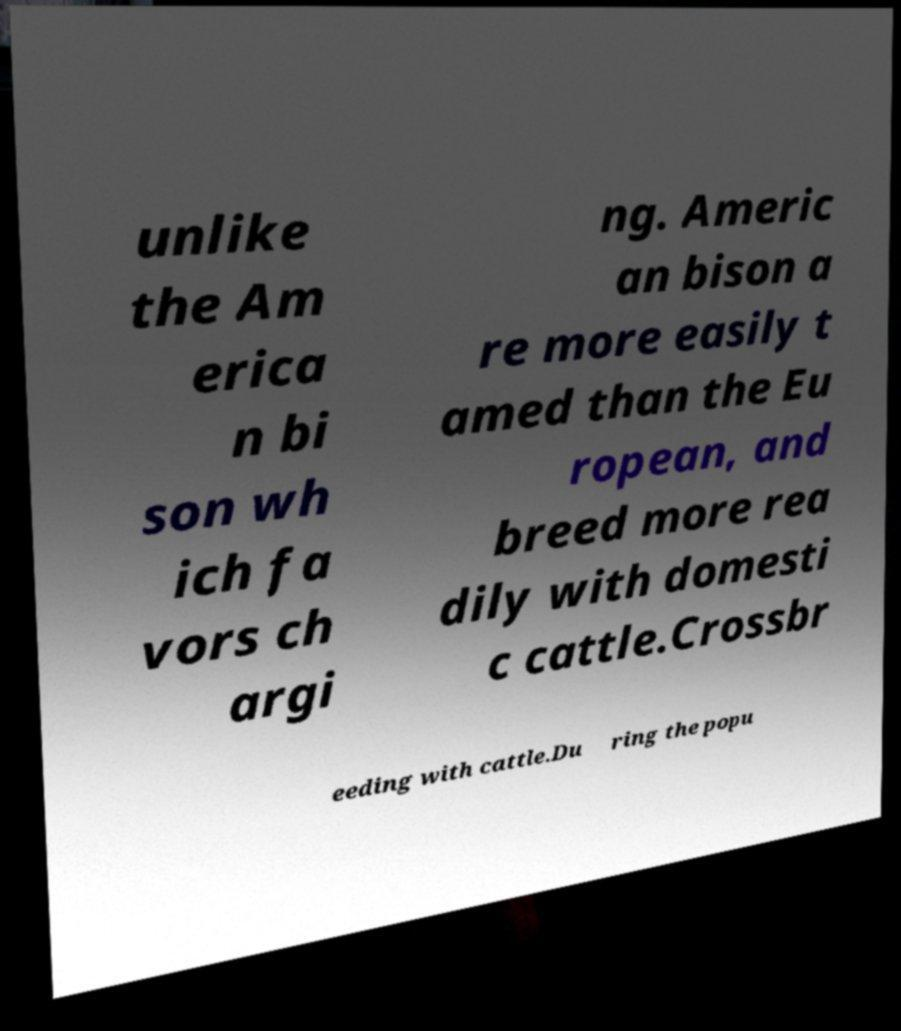Please identify and transcribe the text found in this image. unlike the Am erica n bi son wh ich fa vors ch argi ng. Americ an bison a re more easily t amed than the Eu ropean, and breed more rea dily with domesti c cattle.Crossbr eeding with cattle.Du ring the popu 